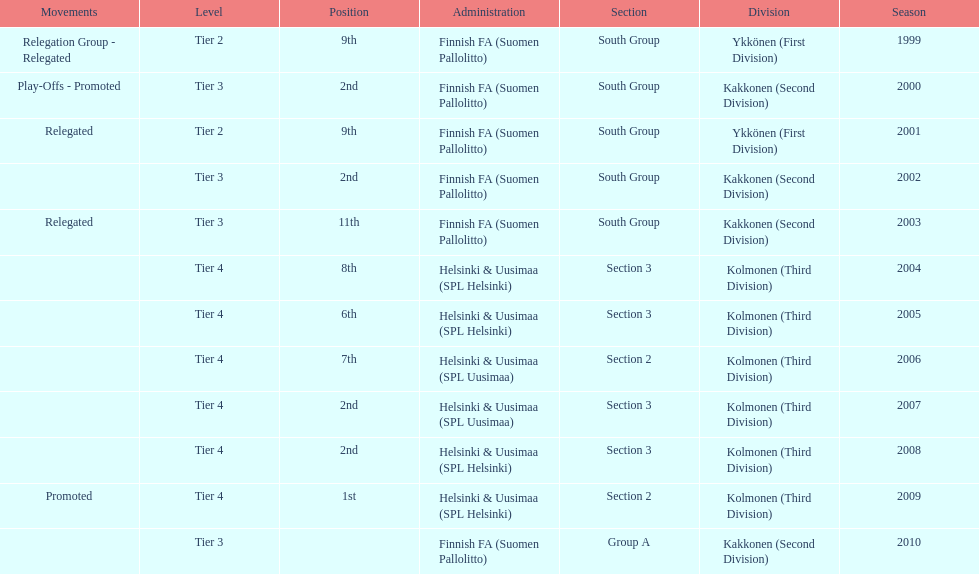In how many levels were multiple relegation movements present? 1. 